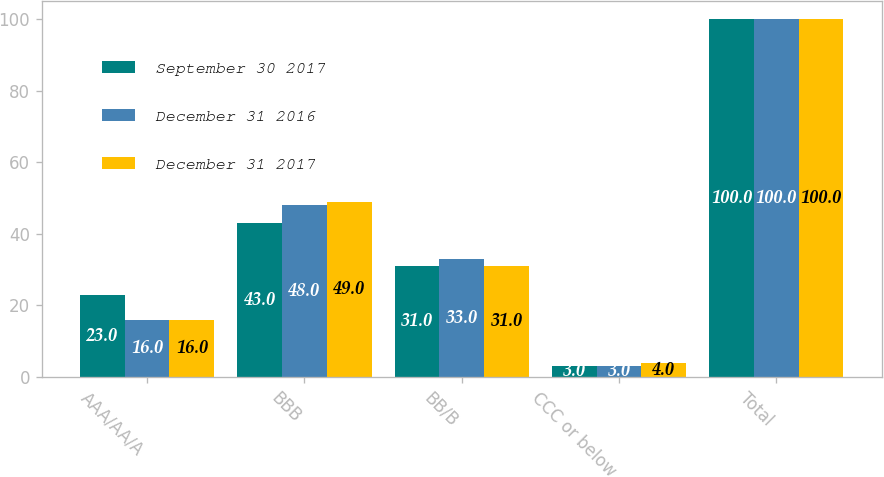<chart> <loc_0><loc_0><loc_500><loc_500><stacked_bar_chart><ecel><fcel>AAA/AA/A<fcel>BBB<fcel>BB/B<fcel>CCC or below<fcel>Total<nl><fcel>September 30 2017<fcel>23<fcel>43<fcel>31<fcel>3<fcel>100<nl><fcel>December 31 2016<fcel>16<fcel>48<fcel>33<fcel>3<fcel>100<nl><fcel>December 31 2017<fcel>16<fcel>49<fcel>31<fcel>4<fcel>100<nl></chart> 